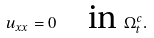Convert formula to latex. <formula><loc_0><loc_0><loc_500><loc_500>u _ { x x } = 0 \quad \text {in } \Omega _ { t } ^ { c } .</formula> 